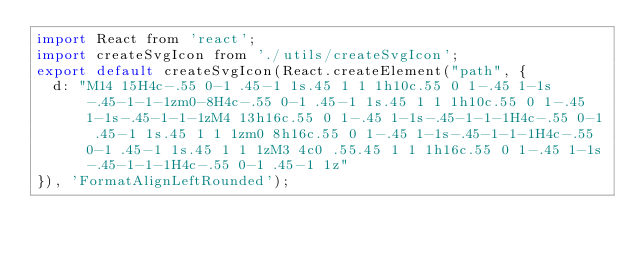Convert code to text. <code><loc_0><loc_0><loc_500><loc_500><_JavaScript_>import React from 'react';
import createSvgIcon from './utils/createSvgIcon';
export default createSvgIcon(React.createElement("path", {
  d: "M14 15H4c-.55 0-1 .45-1 1s.45 1 1 1h10c.55 0 1-.45 1-1s-.45-1-1-1zm0-8H4c-.55 0-1 .45-1 1s.45 1 1 1h10c.55 0 1-.45 1-1s-.45-1-1-1zM4 13h16c.55 0 1-.45 1-1s-.45-1-1-1H4c-.55 0-1 .45-1 1s.45 1 1 1zm0 8h16c.55 0 1-.45 1-1s-.45-1-1-1H4c-.55 0-1 .45-1 1s.45 1 1 1zM3 4c0 .55.45 1 1 1h16c.55 0 1-.45 1-1s-.45-1-1-1H4c-.55 0-1 .45-1 1z"
}), 'FormatAlignLeftRounded');</code> 